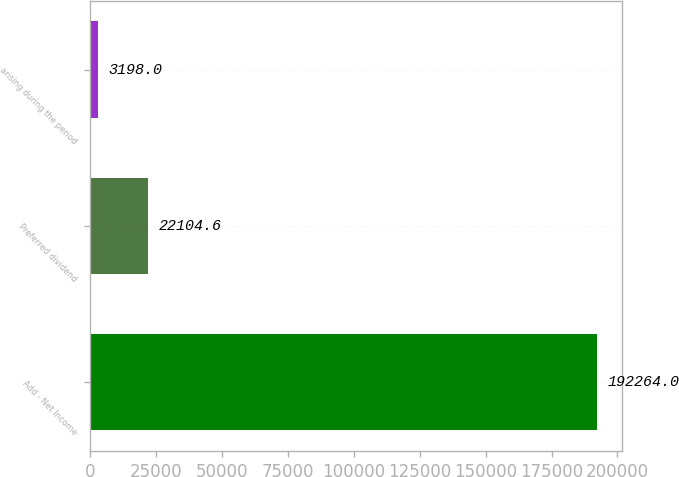Convert chart. <chart><loc_0><loc_0><loc_500><loc_500><bar_chart><fcel>Add - Net Income<fcel>Preferred dividend<fcel>arising during the period<nl><fcel>192264<fcel>22104.6<fcel>3198<nl></chart> 